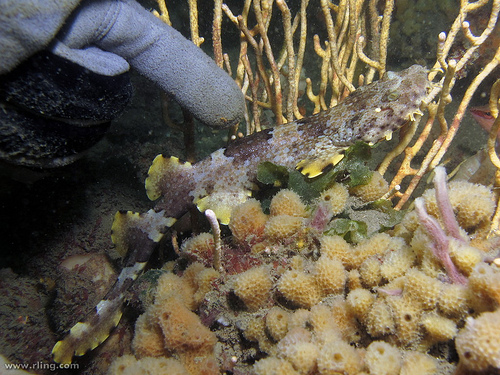<image>
Is there a finger on the fish? No. The finger is not positioned on the fish. They may be near each other, but the finger is not supported by or resting on top of the fish. 